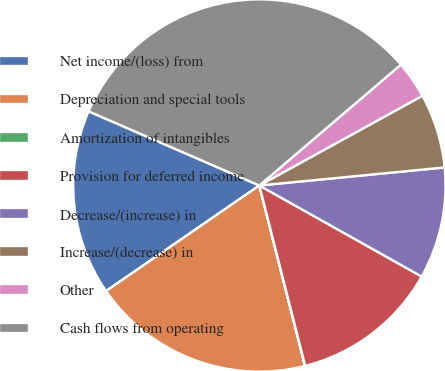<chart> <loc_0><loc_0><loc_500><loc_500><pie_chart><fcel>Net income/(loss) from<fcel>Depreciation and special tools<fcel>Amortization of intangibles<fcel>Provision for deferred income<fcel>Decrease/(increase) in<fcel>Increase/(decrease) in<fcel>Other<fcel>Cash flows from operating<nl><fcel>16.12%<fcel>19.34%<fcel>0.02%<fcel>12.9%<fcel>9.68%<fcel>6.46%<fcel>3.24%<fcel>32.22%<nl></chart> 